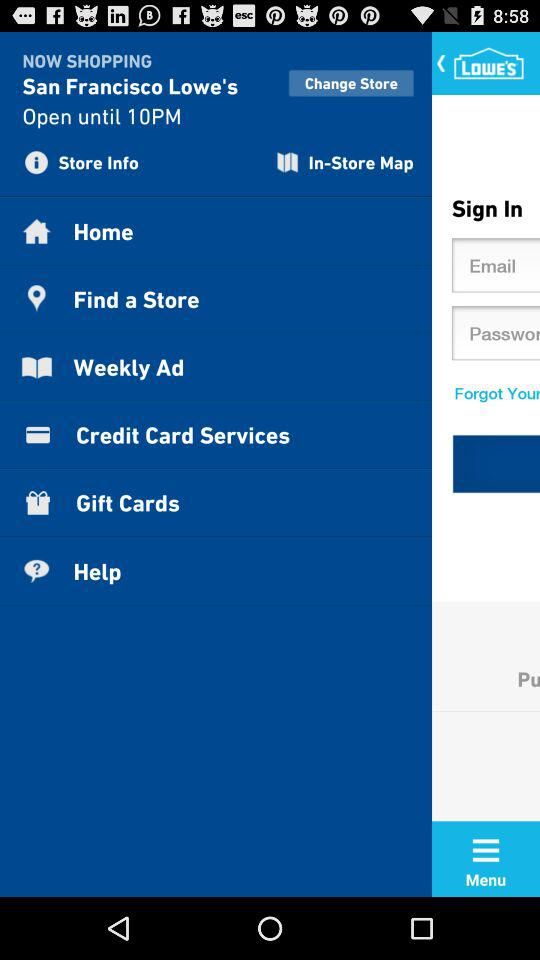What is the name of the store? The name of the store is "LOWE'S". 